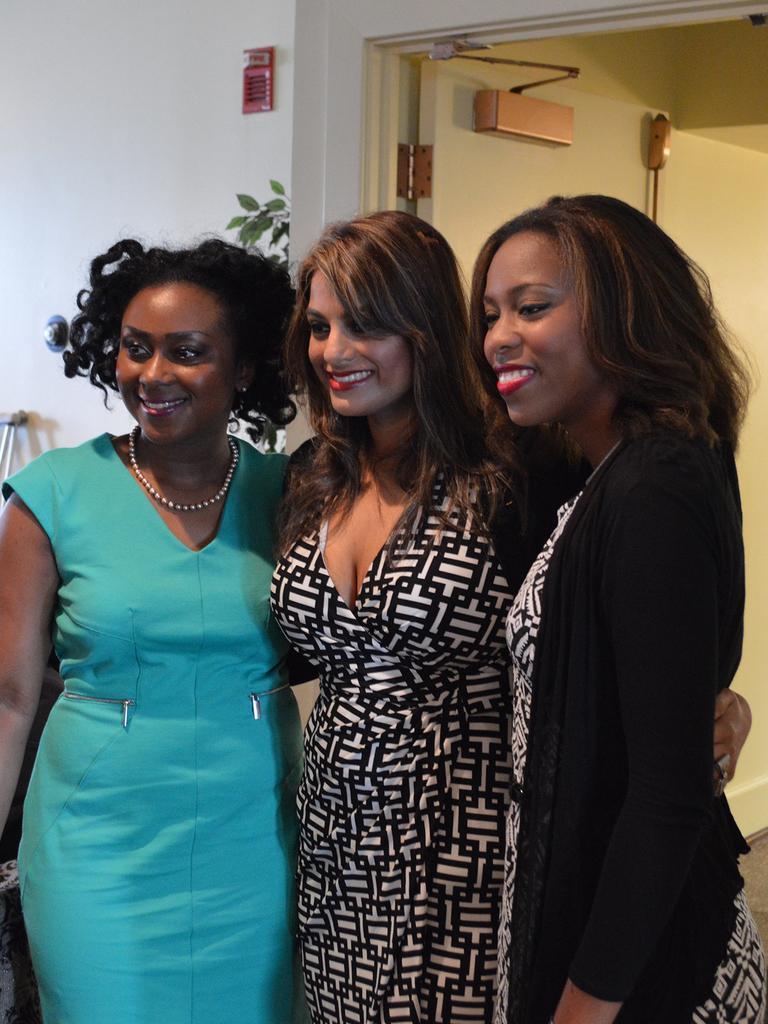How would you summarize this image in a sentence or two? In the picture I can see three women are standing on the floor and smiling. In the background I can see wall, a plant and some other objects. 